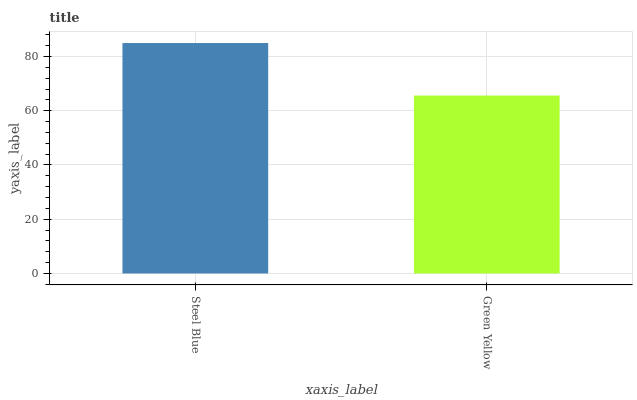Is Green Yellow the minimum?
Answer yes or no. Yes. Is Steel Blue the maximum?
Answer yes or no. Yes. Is Green Yellow the maximum?
Answer yes or no. No. Is Steel Blue greater than Green Yellow?
Answer yes or no. Yes. Is Green Yellow less than Steel Blue?
Answer yes or no. Yes. Is Green Yellow greater than Steel Blue?
Answer yes or no. No. Is Steel Blue less than Green Yellow?
Answer yes or no. No. Is Steel Blue the high median?
Answer yes or no. Yes. Is Green Yellow the low median?
Answer yes or no. Yes. Is Green Yellow the high median?
Answer yes or no. No. Is Steel Blue the low median?
Answer yes or no. No. 